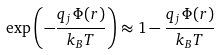<formula> <loc_0><loc_0><loc_500><loc_500>\exp \left ( - { \frac { q _ { j } \, \Phi ( r ) } { k _ { B } T } } \right ) \approx 1 - { \frac { q _ { j } \, \Phi ( r ) } { k _ { B } T } }</formula> 